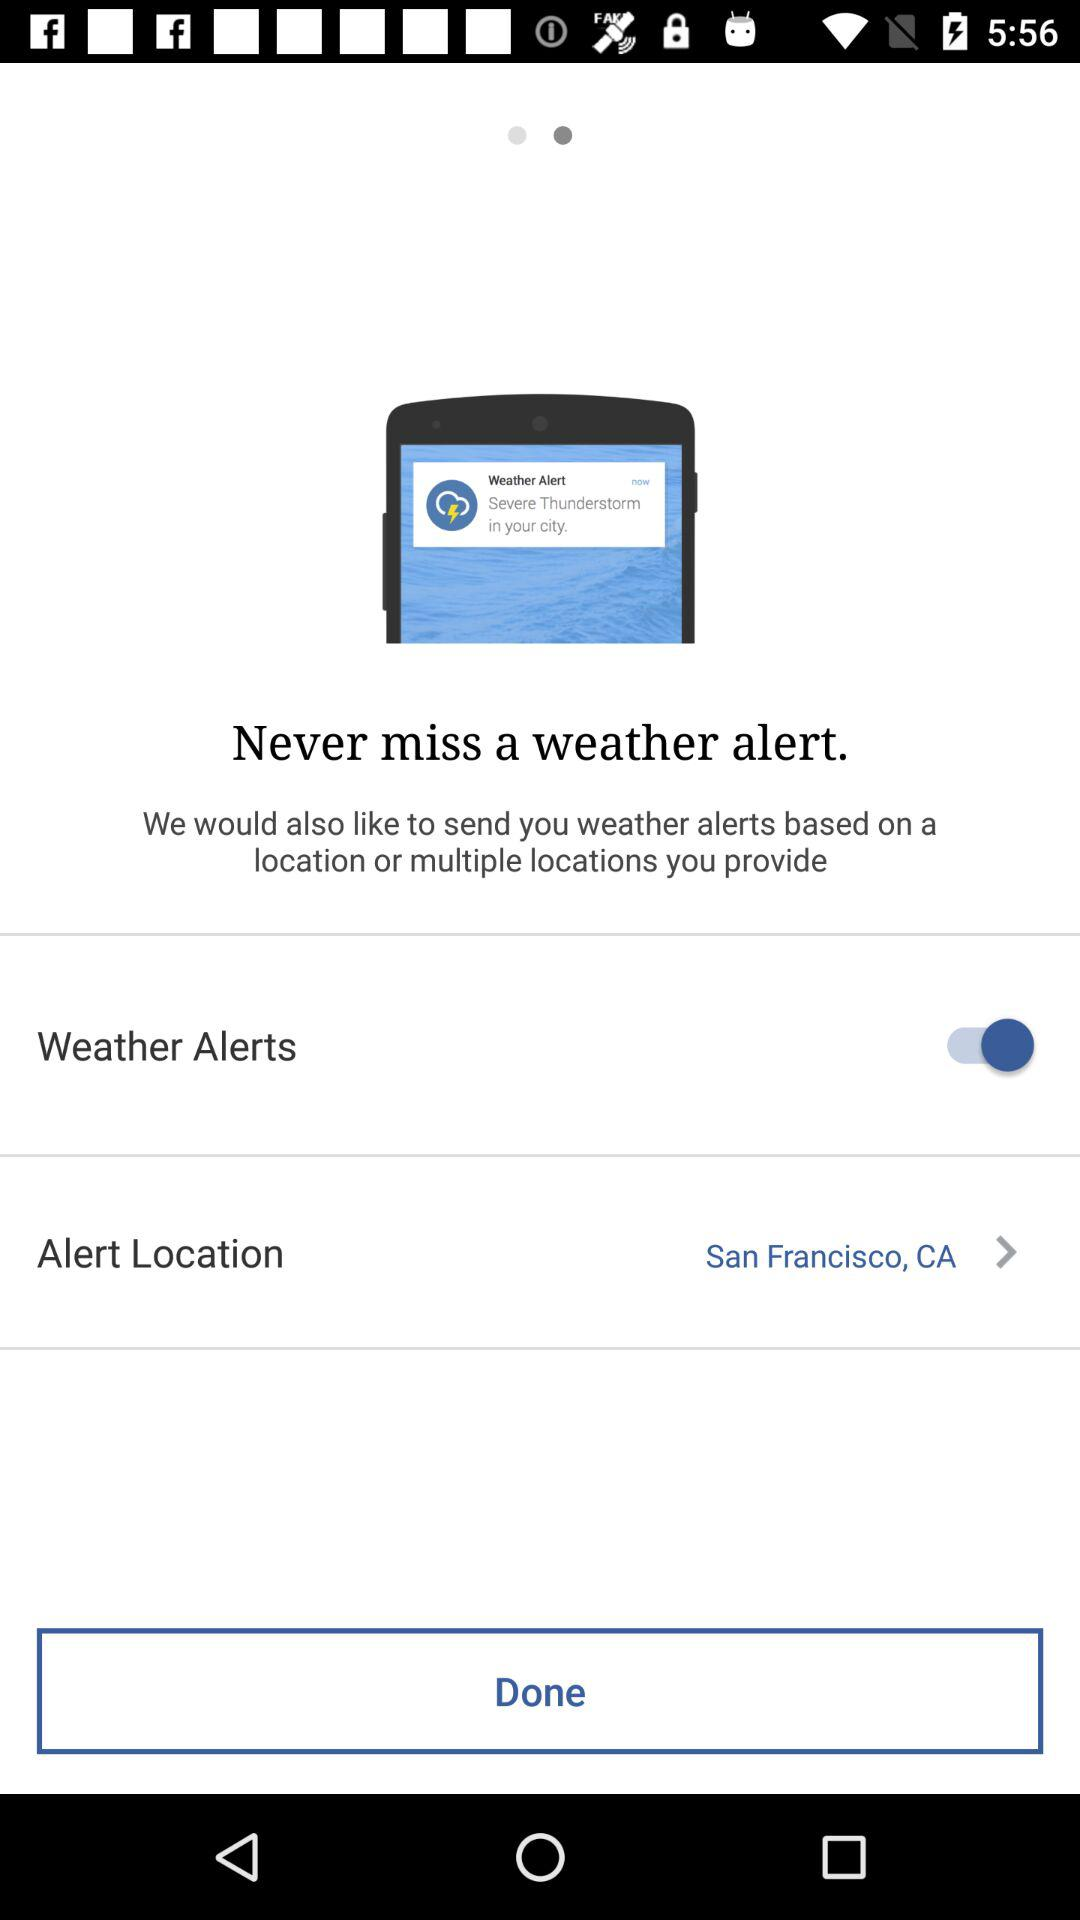What is the status of the "Weather Alerts" switch? The status is "on". 